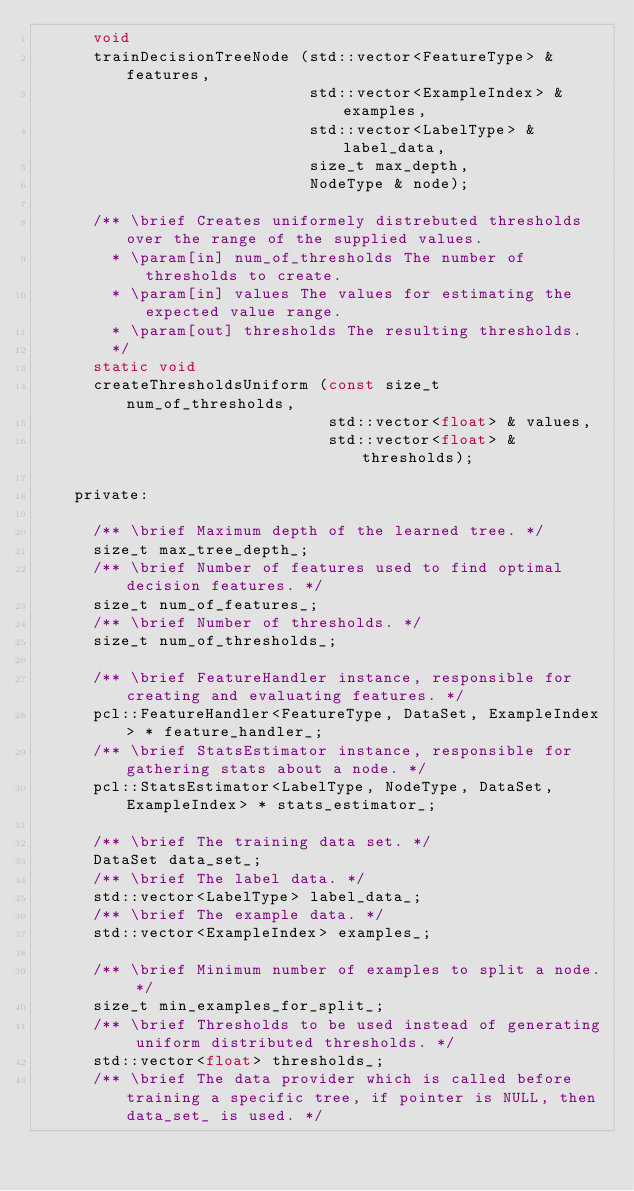<code> <loc_0><loc_0><loc_500><loc_500><_C_>      void
      trainDecisionTreeNode (std::vector<FeatureType> & features,
                             std::vector<ExampleIndex> & examples,
                             std::vector<LabelType> & label_data,
                             size_t max_depth,
                             NodeType & node);

      /** \brief Creates uniformely distrebuted thresholds over the range of the supplied values.
        * \param[in] num_of_thresholds The number of thresholds to create.
        * \param[in] values The values for estimating the expected value range.
        * \param[out] thresholds The resulting thresholds.
        */
      static void
      createThresholdsUniform (const size_t num_of_thresholds,
                               std::vector<float> & values,
                               std::vector<float> & thresholds);

    private:

      /** \brief Maximum depth of the learned tree. */
      size_t max_tree_depth_;
      /** \brief Number of features used to find optimal decision features. */
      size_t num_of_features_;
      /** \brief Number of thresholds. */
      size_t num_of_thresholds_;

      /** \brief FeatureHandler instance, responsible for creating and evaluating features. */
      pcl::FeatureHandler<FeatureType, DataSet, ExampleIndex> * feature_handler_;
      /** \brief StatsEstimator instance, responsible for gathering stats about a node. */
      pcl::StatsEstimator<LabelType, NodeType, DataSet, ExampleIndex> * stats_estimator_;

      /** \brief The training data set. */
      DataSet data_set_;
      /** \brief The label data. */
      std::vector<LabelType> label_data_;
      /** \brief The example data. */
      std::vector<ExampleIndex> examples_;
  
      /** \brief Minimum number of examples to split a node. */
      size_t min_examples_for_split_;
      /** \brief Thresholds to be used instead of generating uniform distributed thresholds. */
      std::vector<float> thresholds_;
      /** \brief The data provider which is called before training a specific tree, if pointer is NULL, then data_set_ is used. */</code> 